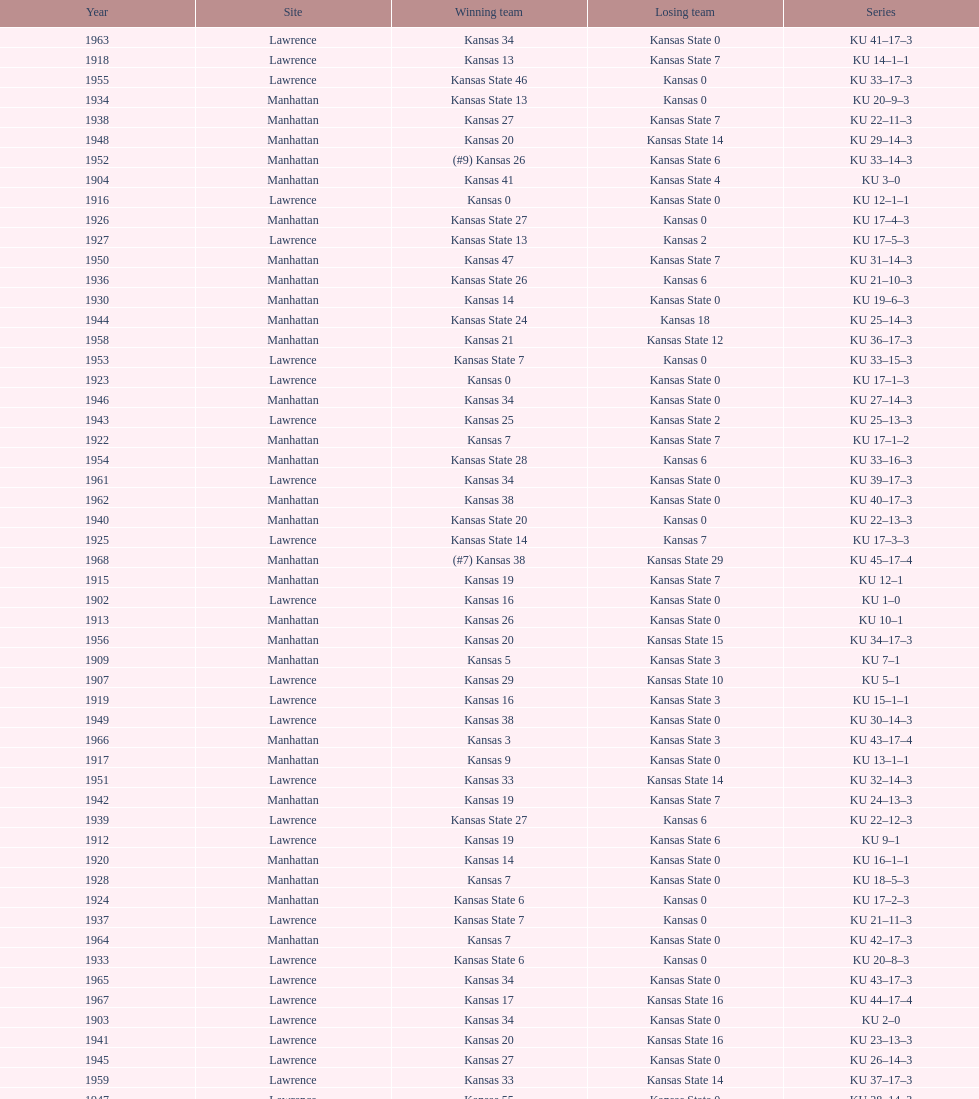Who had the most wins in the 1950's: kansas or kansas state? Kansas. 